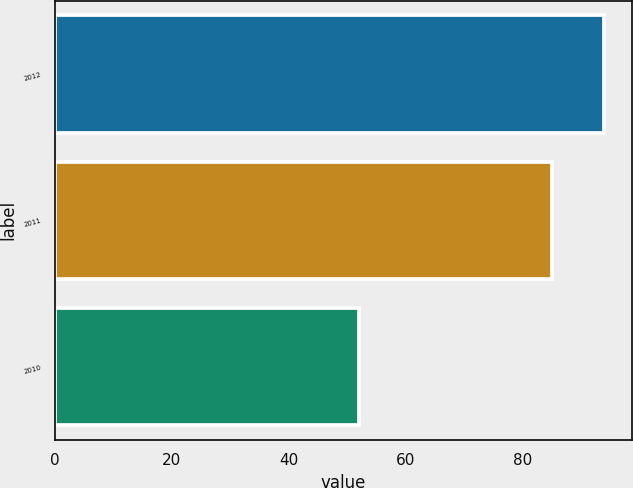<chart> <loc_0><loc_0><loc_500><loc_500><bar_chart><fcel>2012<fcel>2011<fcel>2010<nl><fcel>94<fcel>85<fcel>52<nl></chart> 